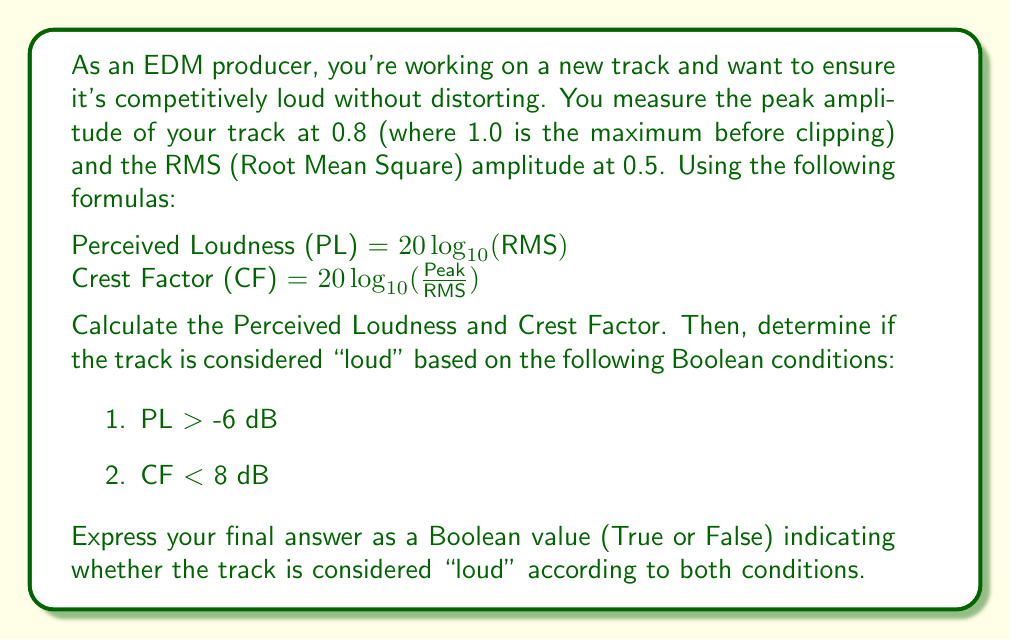Can you solve this math problem? Let's break this down step-by-step:

1. Calculate Perceived Loudness (PL):
   $PL = 20 \log_{10}(\text{RMS})$
   $PL = 20 \log_{10}(0.5)$
   $PL = 20 \cdot (-0.301)$
   $PL \approx -6.02$ dB

2. Calculate Crest Factor (CF):
   $CF = 20 \log_{10}(\frac{\text{Peak}}{\text{RMS}})$
   $CF = 20 \log_{10}(\frac{0.8}{0.5})$
   $CF = 20 \log_{10}(1.6)$
   $CF = 20 \cdot 0.204$
   $CF \approx 4.08$ dB

3. Check the conditions:
   Condition 1: Is PL > -6 dB?
   $-6.02 > -6$ is false

   Condition 2: Is CF < 8 dB?
   $4.08 < 8$ is true

4. For the track to be considered "loud", both conditions must be true.
   We can express this using Boolean algebra as:
   $\text{Loud} = (\text{PL} > -6) \land (\text{CF} < 8)$

   Where $\land$ represents the logical AND operation.

5. Substituting our results:
   $\text{Loud} = \text{False} \land \text{True} = \text{False}$

Therefore, the track is not considered "loud" according to both conditions.
Answer: False 